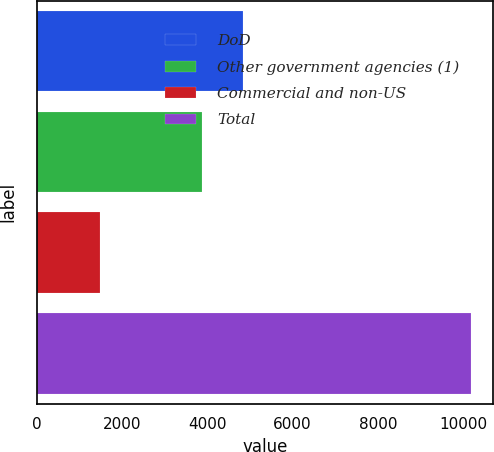Convert chart. <chart><loc_0><loc_0><loc_500><loc_500><bar_chart><fcel>DoD<fcel>Other government agencies (1)<fcel>Commercial and non-US<fcel>Total<nl><fcel>4832<fcel>3882<fcel>1480<fcel>10194<nl></chart> 